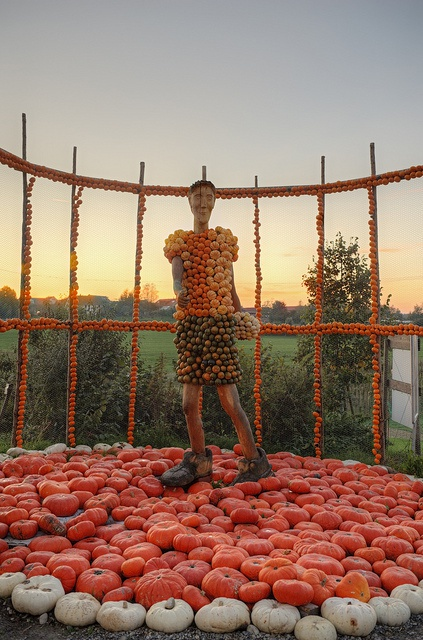Describe the objects in this image and their specific colors. I can see people in darkgray, maroon, black, and brown tones, orange in darkgray, maroon, black, and brown tones, orange in darkgray, brown, tan, and maroon tones, orange in darkgray, brown, maroon, and tan tones, and orange in darkgray, maroon, brown, and black tones in this image. 